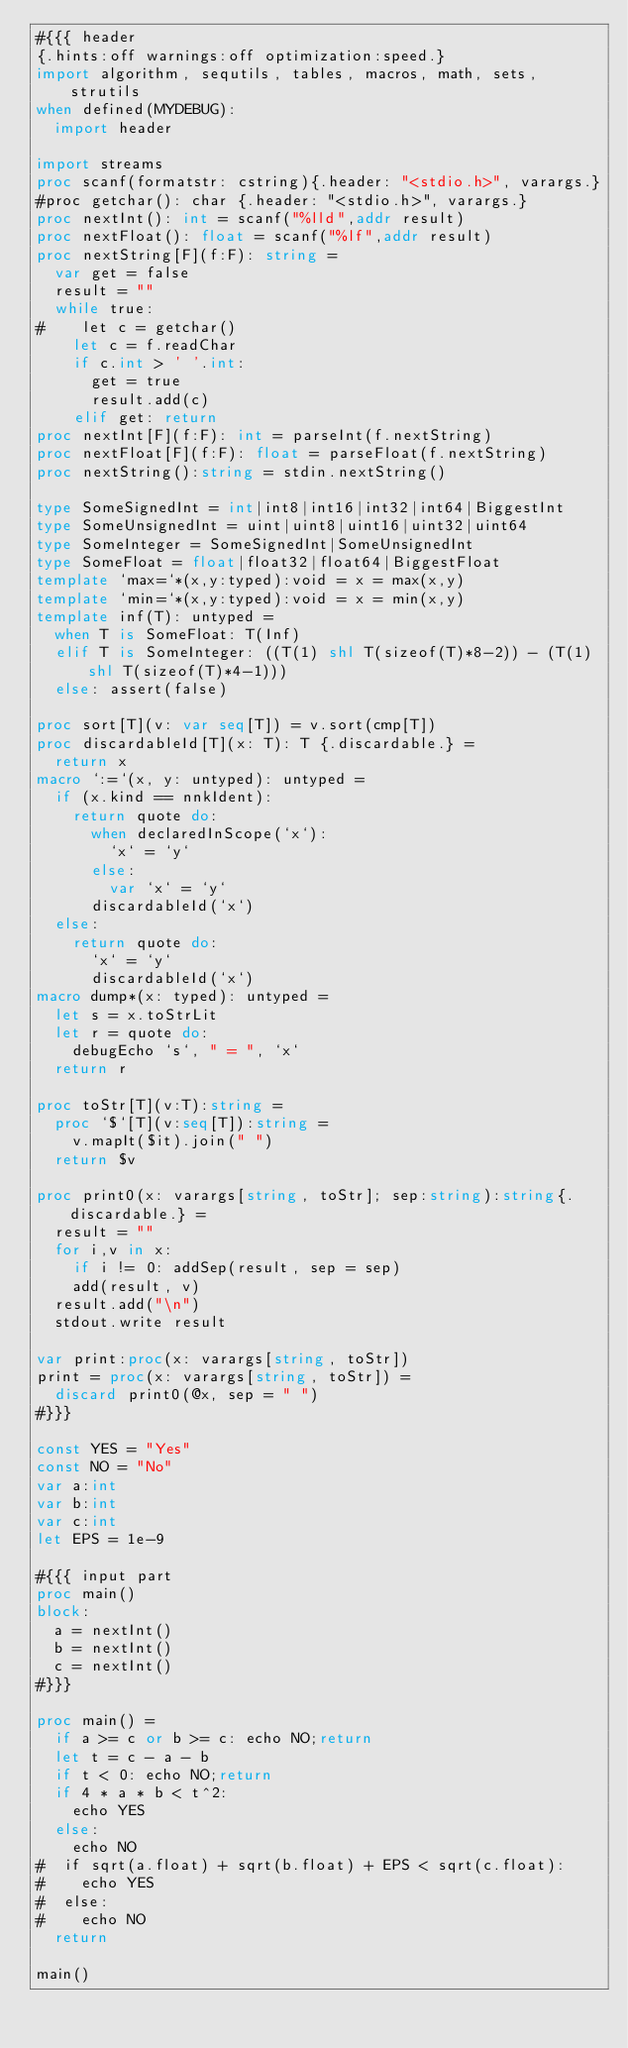<code> <loc_0><loc_0><loc_500><loc_500><_Nim_>#{{{ header
{.hints:off warnings:off optimization:speed.}
import algorithm, sequtils, tables, macros, math, sets, strutils
when defined(MYDEBUG):
  import header

import streams
proc scanf(formatstr: cstring){.header: "<stdio.h>", varargs.}
#proc getchar(): char {.header: "<stdio.h>", varargs.}
proc nextInt(): int = scanf("%lld",addr result)
proc nextFloat(): float = scanf("%lf",addr result)
proc nextString[F](f:F): string =
  var get = false
  result = ""
  while true:
#    let c = getchar()
    let c = f.readChar
    if c.int > ' '.int:
      get = true
      result.add(c)
    elif get: return
proc nextInt[F](f:F): int = parseInt(f.nextString)
proc nextFloat[F](f:F): float = parseFloat(f.nextString)
proc nextString():string = stdin.nextString()

type SomeSignedInt = int|int8|int16|int32|int64|BiggestInt
type SomeUnsignedInt = uint|uint8|uint16|uint32|uint64
type SomeInteger = SomeSignedInt|SomeUnsignedInt
type SomeFloat = float|float32|float64|BiggestFloat
template `max=`*(x,y:typed):void = x = max(x,y)
template `min=`*(x,y:typed):void = x = min(x,y)
template inf(T): untyped = 
  when T is SomeFloat: T(Inf)
  elif T is SomeInteger: ((T(1) shl T(sizeof(T)*8-2)) - (T(1) shl T(sizeof(T)*4-1)))
  else: assert(false)

proc sort[T](v: var seq[T]) = v.sort(cmp[T])
proc discardableId[T](x: T): T {.discardable.} =
  return x
macro `:=`(x, y: untyped): untyped =
  if (x.kind == nnkIdent):
    return quote do:
      when declaredInScope(`x`):
        `x` = `y`
      else:
        var `x` = `y`
      discardableId(`x`)
  else:
    return quote do:
      `x` = `y`
      discardableId(`x`)
macro dump*(x: typed): untyped =
  let s = x.toStrLit
  let r = quote do:
    debugEcho `s`, " = ", `x`
  return r

proc toStr[T](v:T):string =
  proc `$`[T](v:seq[T]):string =
    v.mapIt($it).join(" ")
  return $v

proc print0(x: varargs[string, toStr]; sep:string):string{.discardable.} =
  result = ""
  for i,v in x:
    if i != 0: addSep(result, sep = sep)
    add(result, v)
  result.add("\n")
  stdout.write result

var print:proc(x: varargs[string, toStr])
print = proc(x: varargs[string, toStr]) =
  discard print0(@x, sep = " ")
#}}}

const YES = "Yes"
const NO = "No"
var a:int
var b:int
var c:int
let EPS = 1e-9

#{{{ input part
proc main()
block:
  a = nextInt()
  b = nextInt()
  c = nextInt()
#}}}

proc main() =
  if a >= c or b >= c: echo NO;return
  let t = c - a - b
  if t < 0: echo NO;return
  if 4 * a * b < t^2:
    echo YES
  else:
    echo NO
#  if sqrt(a.float) + sqrt(b.float) + EPS < sqrt(c.float):
#    echo YES
#  else:
#    echo NO
  return

main()</code> 